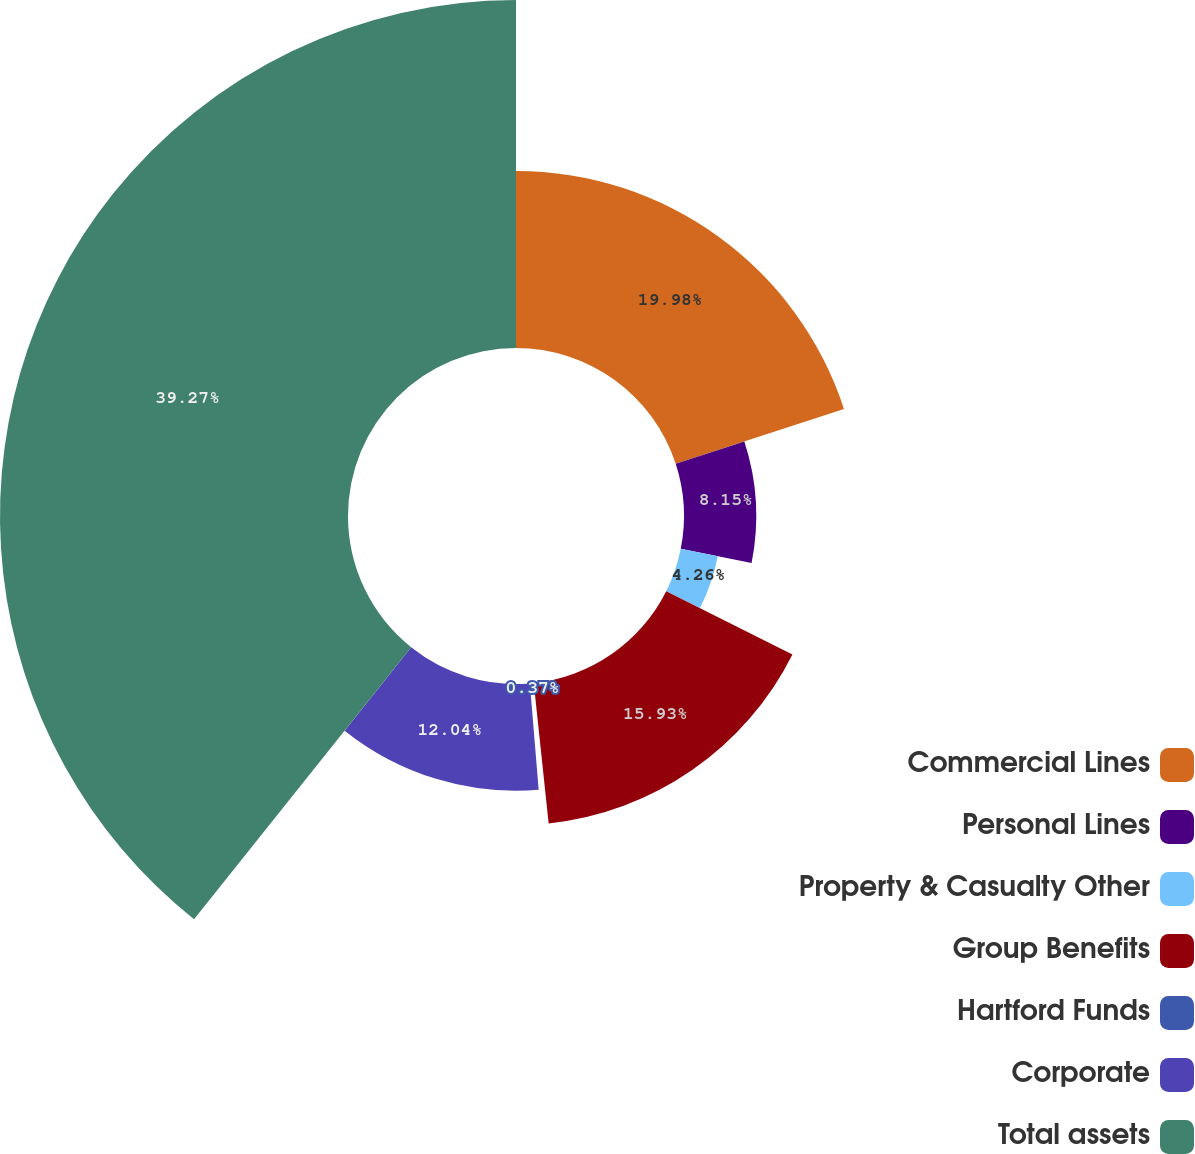Convert chart. <chart><loc_0><loc_0><loc_500><loc_500><pie_chart><fcel>Commercial Lines<fcel>Personal Lines<fcel>Property & Casualty Other<fcel>Group Benefits<fcel>Hartford Funds<fcel>Corporate<fcel>Total assets<nl><fcel>19.98%<fcel>8.15%<fcel>4.26%<fcel>15.93%<fcel>0.37%<fcel>12.04%<fcel>39.28%<nl></chart> 